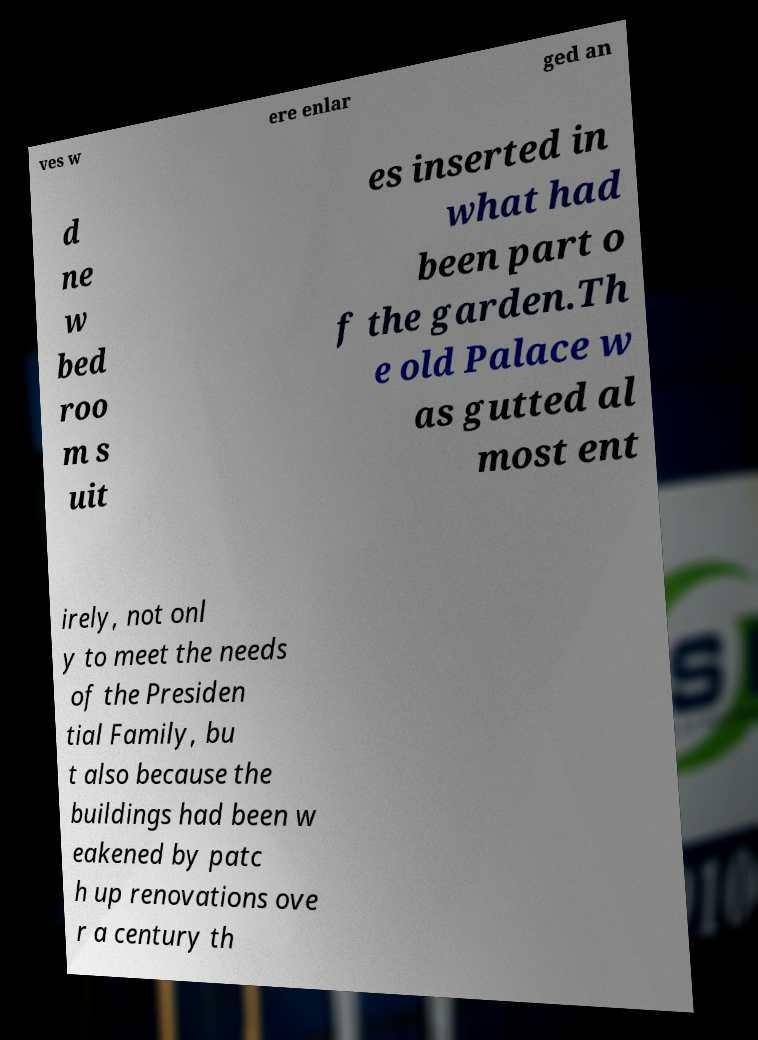Can you accurately transcribe the text from the provided image for me? ves w ere enlar ged an d ne w bed roo m s uit es inserted in what had been part o f the garden.Th e old Palace w as gutted al most ent irely, not onl y to meet the needs of the Presiden tial Family, bu t also because the buildings had been w eakened by patc h up renovations ove r a century th 